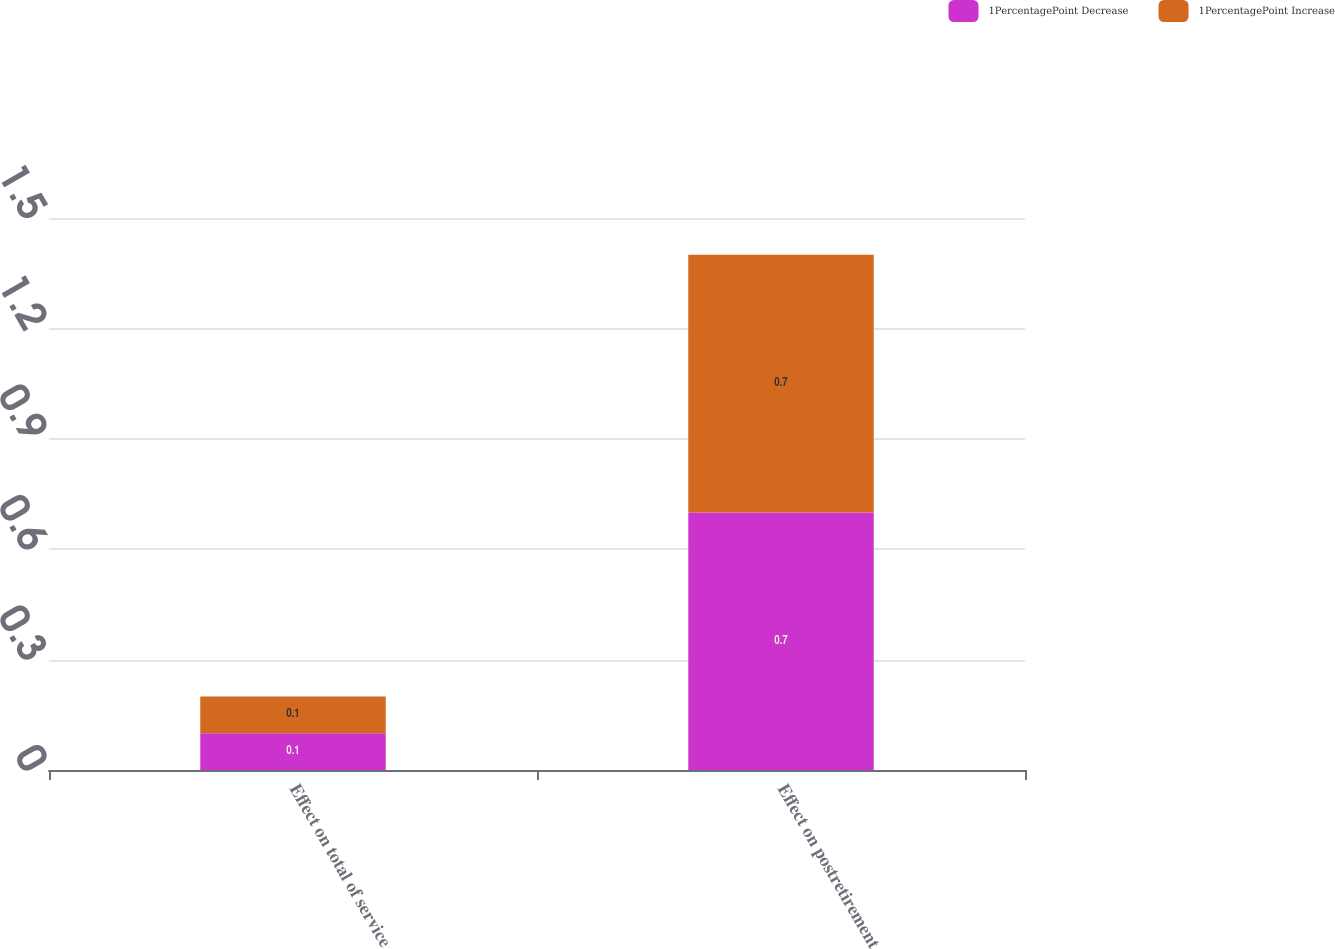Convert chart. <chart><loc_0><loc_0><loc_500><loc_500><stacked_bar_chart><ecel><fcel>Effect on total of service<fcel>Effect on postretirement<nl><fcel>1PercentagePoint Decrease<fcel>0.1<fcel>0.7<nl><fcel>1PercentagePoint Increase<fcel>0.1<fcel>0.7<nl></chart> 